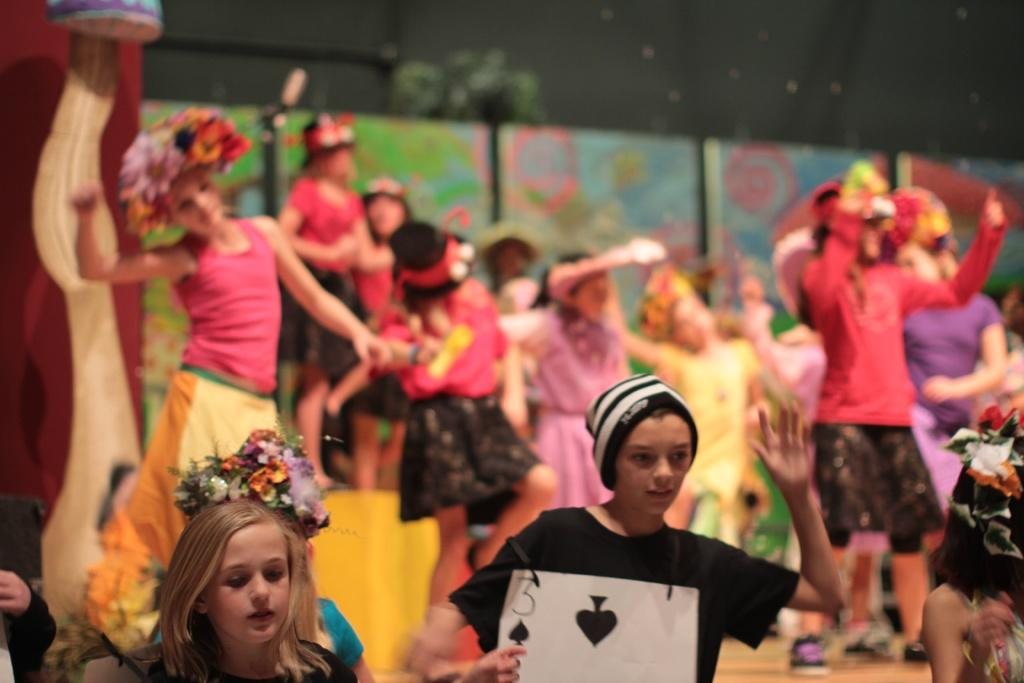What are the people in the image doing? The people in the image are dancing. Can you describe the attire of some of the people? Some of the people are wearing hats. What can be seen on the wall in the image? There are boards on the wall. What is featured on the poster in the image? The poster in the image has numbers and pictures. What type of thrill can be seen on the root of the zinc plant in the image? There is no zinc plant or root present in the image. The image features people dancing, hats, boards on the wall, and a poster with numbers and pictures. 